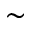Convert formula to latex. <formula><loc_0><loc_0><loc_500><loc_500>\sim</formula> 